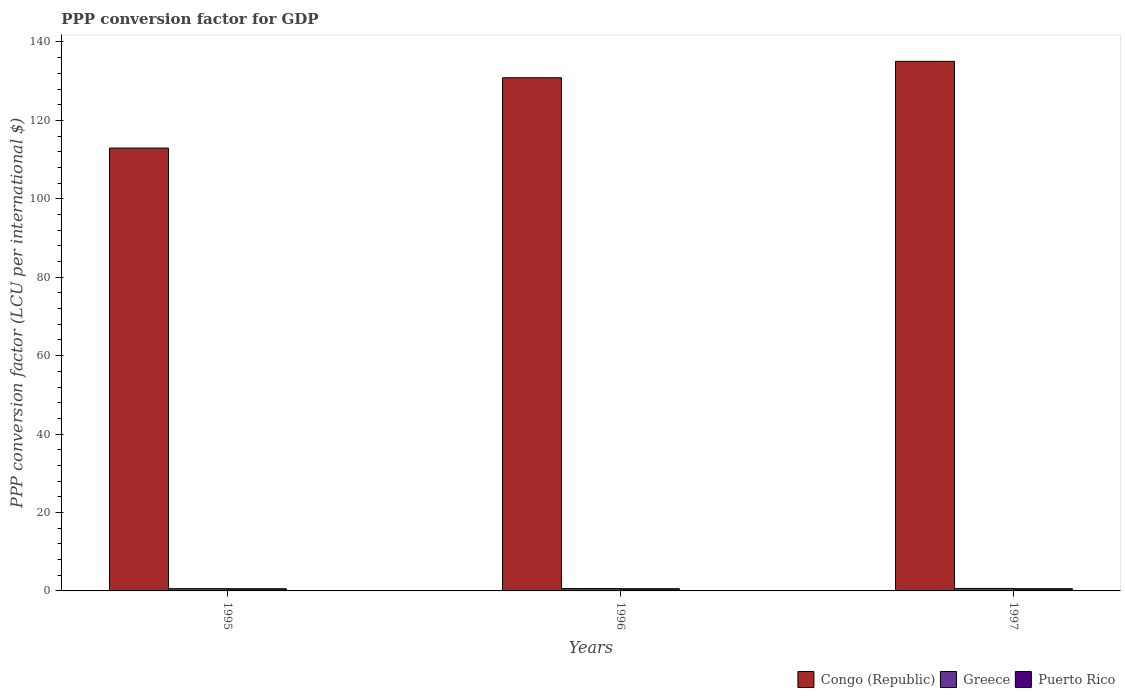How many different coloured bars are there?
Give a very brief answer. 3. How many groups of bars are there?
Keep it short and to the point. 3. Are the number of bars per tick equal to the number of legend labels?
Make the answer very short. Yes. Are the number of bars on each tick of the X-axis equal?
Provide a succinct answer. Yes. How many bars are there on the 3rd tick from the left?
Offer a very short reply. 3. How many bars are there on the 2nd tick from the right?
Offer a terse response. 3. What is the label of the 1st group of bars from the left?
Ensure brevity in your answer.  1995. What is the PPP conversion factor for GDP in Puerto Rico in 1995?
Provide a short and direct response. 0.55. Across all years, what is the maximum PPP conversion factor for GDP in Puerto Rico?
Offer a terse response. 0.57. Across all years, what is the minimum PPP conversion factor for GDP in Puerto Rico?
Provide a succinct answer. 0.55. In which year was the PPP conversion factor for GDP in Congo (Republic) maximum?
Your response must be concise. 1997. In which year was the PPP conversion factor for GDP in Congo (Republic) minimum?
Provide a succinct answer. 1995. What is the total PPP conversion factor for GDP in Greece in the graph?
Ensure brevity in your answer.  1.81. What is the difference between the PPP conversion factor for GDP in Congo (Republic) in 1995 and that in 1997?
Your answer should be very brief. -22.12. What is the difference between the PPP conversion factor for GDP in Puerto Rico in 1997 and the PPP conversion factor for GDP in Congo (Republic) in 1996?
Keep it short and to the point. -130.3. What is the average PPP conversion factor for GDP in Greece per year?
Provide a short and direct response. 0.6. In the year 1995, what is the difference between the PPP conversion factor for GDP in Greece and PPP conversion factor for GDP in Puerto Rico?
Your answer should be very brief. 0.02. In how many years, is the PPP conversion factor for GDP in Puerto Rico greater than 28 LCU?
Your answer should be compact. 0. What is the ratio of the PPP conversion factor for GDP in Congo (Republic) in 1996 to that in 1997?
Provide a short and direct response. 0.97. Is the PPP conversion factor for GDP in Puerto Rico in 1996 less than that in 1997?
Give a very brief answer. Yes. Is the difference between the PPP conversion factor for GDP in Greece in 1996 and 1997 greater than the difference between the PPP conversion factor for GDP in Puerto Rico in 1996 and 1997?
Your answer should be very brief. No. What is the difference between the highest and the second highest PPP conversion factor for GDP in Puerto Rico?
Make the answer very short. 0.01. What is the difference between the highest and the lowest PPP conversion factor for GDP in Greece?
Provide a succinct answer. 0.06. In how many years, is the PPP conversion factor for GDP in Congo (Republic) greater than the average PPP conversion factor for GDP in Congo (Republic) taken over all years?
Make the answer very short. 2. What does the 3rd bar from the left in 1995 represents?
Your answer should be very brief. Puerto Rico. Is it the case that in every year, the sum of the PPP conversion factor for GDP in Congo (Republic) and PPP conversion factor for GDP in Greece is greater than the PPP conversion factor for GDP in Puerto Rico?
Provide a succinct answer. Yes. How many bars are there?
Your response must be concise. 9. Are all the bars in the graph horizontal?
Provide a short and direct response. No. Does the graph contain grids?
Ensure brevity in your answer.  No. What is the title of the graph?
Ensure brevity in your answer.  PPP conversion factor for GDP. What is the label or title of the Y-axis?
Keep it short and to the point. PPP conversion factor (LCU per international $). What is the PPP conversion factor (LCU per international $) in Congo (Republic) in 1995?
Keep it short and to the point. 112.94. What is the PPP conversion factor (LCU per international $) in Greece in 1995?
Your answer should be compact. 0.57. What is the PPP conversion factor (LCU per international $) of Puerto Rico in 1995?
Make the answer very short. 0.55. What is the PPP conversion factor (LCU per international $) in Congo (Republic) in 1996?
Your response must be concise. 130.87. What is the PPP conversion factor (LCU per international $) of Greece in 1996?
Offer a terse response. 0.61. What is the PPP conversion factor (LCU per international $) of Puerto Rico in 1996?
Make the answer very short. 0.56. What is the PPP conversion factor (LCU per international $) of Congo (Republic) in 1997?
Your answer should be compact. 135.06. What is the PPP conversion factor (LCU per international $) in Greece in 1997?
Offer a terse response. 0.63. What is the PPP conversion factor (LCU per international $) in Puerto Rico in 1997?
Provide a short and direct response. 0.57. Across all years, what is the maximum PPP conversion factor (LCU per international $) of Congo (Republic)?
Your answer should be very brief. 135.06. Across all years, what is the maximum PPP conversion factor (LCU per international $) in Greece?
Your answer should be very brief. 0.63. Across all years, what is the maximum PPP conversion factor (LCU per international $) of Puerto Rico?
Your response must be concise. 0.57. Across all years, what is the minimum PPP conversion factor (LCU per international $) of Congo (Republic)?
Make the answer very short. 112.94. Across all years, what is the minimum PPP conversion factor (LCU per international $) in Greece?
Provide a succinct answer. 0.57. Across all years, what is the minimum PPP conversion factor (LCU per international $) in Puerto Rico?
Your answer should be very brief. 0.55. What is the total PPP conversion factor (LCU per international $) of Congo (Republic) in the graph?
Your response must be concise. 378.87. What is the total PPP conversion factor (LCU per international $) of Greece in the graph?
Your response must be concise. 1.81. What is the total PPP conversion factor (LCU per international $) of Puerto Rico in the graph?
Your answer should be compact. 1.69. What is the difference between the PPP conversion factor (LCU per international $) of Congo (Republic) in 1995 and that in 1996?
Provide a short and direct response. -17.93. What is the difference between the PPP conversion factor (LCU per international $) of Greece in 1995 and that in 1996?
Provide a succinct answer. -0.03. What is the difference between the PPP conversion factor (LCU per international $) in Puerto Rico in 1995 and that in 1996?
Provide a succinct answer. -0.01. What is the difference between the PPP conversion factor (LCU per international $) in Congo (Republic) in 1995 and that in 1997?
Keep it short and to the point. -22.12. What is the difference between the PPP conversion factor (LCU per international $) of Greece in 1995 and that in 1997?
Your response must be concise. -0.06. What is the difference between the PPP conversion factor (LCU per international $) in Puerto Rico in 1995 and that in 1997?
Offer a very short reply. -0.02. What is the difference between the PPP conversion factor (LCU per international $) of Congo (Republic) in 1996 and that in 1997?
Ensure brevity in your answer.  -4.19. What is the difference between the PPP conversion factor (LCU per international $) in Greece in 1996 and that in 1997?
Offer a very short reply. -0.03. What is the difference between the PPP conversion factor (LCU per international $) in Puerto Rico in 1996 and that in 1997?
Offer a very short reply. -0.01. What is the difference between the PPP conversion factor (LCU per international $) of Congo (Republic) in 1995 and the PPP conversion factor (LCU per international $) of Greece in 1996?
Give a very brief answer. 112.34. What is the difference between the PPP conversion factor (LCU per international $) in Congo (Republic) in 1995 and the PPP conversion factor (LCU per international $) in Puerto Rico in 1996?
Your response must be concise. 112.38. What is the difference between the PPP conversion factor (LCU per international $) in Greece in 1995 and the PPP conversion factor (LCU per international $) in Puerto Rico in 1996?
Ensure brevity in your answer.  0.01. What is the difference between the PPP conversion factor (LCU per international $) of Congo (Republic) in 1995 and the PPP conversion factor (LCU per international $) of Greece in 1997?
Provide a short and direct response. 112.31. What is the difference between the PPP conversion factor (LCU per international $) of Congo (Republic) in 1995 and the PPP conversion factor (LCU per international $) of Puerto Rico in 1997?
Your answer should be very brief. 112.37. What is the difference between the PPP conversion factor (LCU per international $) of Greece in 1995 and the PPP conversion factor (LCU per international $) of Puerto Rico in 1997?
Ensure brevity in your answer.  0. What is the difference between the PPP conversion factor (LCU per international $) in Congo (Republic) in 1996 and the PPP conversion factor (LCU per international $) in Greece in 1997?
Your response must be concise. 130.24. What is the difference between the PPP conversion factor (LCU per international $) of Congo (Republic) in 1996 and the PPP conversion factor (LCU per international $) of Puerto Rico in 1997?
Your answer should be very brief. 130.3. What is the difference between the PPP conversion factor (LCU per international $) in Greece in 1996 and the PPP conversion factor (LCU per international $) in Puerto Rico in 1997?
Offer a very short reply. 0.03. What is the average PPP conversion factor (LCU per international $) of Congo (Republic) per year?
Keep it short and to the point. 126.29. What is the average PPP conversion factor (LCU per international $) of Greece per year?
Offer a terse response. 0.6. What is the average PPP conversion factor (LCU per international $) of Puerto Rico per year?
Offer a terse response. 0.56. In the year 1995, what is the difference between the PPP conversion factor (LCU per international $) of Congo (Republic) and PPP conversion factor (LCU per international $) of Greece?
Ensure brevity in your answer.  112.37. In the year 1995, what is the difference between the PPP conversion factor (LCU per international $) in Congo (Republic) and PPP conversion factor (LCU per international $) in Puerto Rico?
Your answer should be very brief. 112.39. In the year 1995, what is the difference between the PPP conversion factor (LCU per international $) in Greece and PPP conversion factor (LCU per international $) in Puerto Rico?
Make the answer very short. 0.02. In the year 1996, what is the difference between the PPP conversion factor (LCU per international $) of Congo (Republic) and PPP conversion factor (LCU per international $) of Greece?
Your answer should be compact. 130.27. In the year 1996, what is the difference between the PPP conversion factor (LCU per international $) of Congo (Republic) and PPP conversion factor (LCU per international $) of Puerto Rico?
Ensure brevity in your answer.  130.31. In the year 1996, what is the difference between the PPP conversion factor (LCU per international $) in Greece and PPP conversion factor (LCU per international $) in Puerto Rico?
Your answer should be very brief. 0.04. In the year 1997, what is the difference between the PPP conversion factor (LCU per international $) in Congo (Republic) and PPP conversion factor (LCU per international $) in Greece?
Provide a short and direct response. 134.43. In the year 1997, what is the difference between the PPP conversion factor (LCU per international $) of Congo (Republic) and PPP conversion factor (LCU per international $) of Puerto Rico?
Provide a succinct answer. 134.49. In the year 1997, what is the difference between the PPP conversion factor (LCU per international $) in Greece and PPP conversion factor (LCU per international $) in Puerto Rico?
Provide a succinct answer. 0.06. What is the ratio of the PPP conversion factor (LCU per international $) of Congo (Republic) in 1995 to that in 1996?
Provide a succinct answer. 0.86. What is the ratio of the PPP conversion factor (LCU per international $) in Greece in 1995 to that in 1996?
Keep it short and to the point. 0.95. What is the ratio of the PPP conversion factor (LCU per international $) in Puerto Rico in 1995 to that in 1996?
Provide a short and direct response. 0.99. What is the ratio of the PPP conversion factor (LCU per international $) of Congo (Republic) in 1995 to that in 1997?
Your answer should be very brief. 0.84. What is the ratio of the PPP conversion factor (LCU per international $) in Greece in 1995 to that in 1997?
Your answer should be very brief. 0.91. What is the ratio of the PPP conversion factor (LCU per international $) in Puerto Rico in 1995 to that in 1997?
Make the answer very short. 0.97. What is the ratio of the PPP conversion factor (LCU per international $) in Congo (Republic) in 1996 to that in 1997?
Keep it short and to the point. 0.97. What is the ratio of the PPP conversion factor (LCU per international $) of Greece in 1996 to that in 1997?
Your answer should be compact. 0.96. What is the ratio of the PPP conversion factor (LCU per international $) of Puerto Rico in 1996 to that in 1997?
Your response must be concise. 0.99. What is the difference between the highest and the second highest PPP conversion factor (LCU per international $) of Congo (Republic)?
Ensure brevity in your answer.  4.19. What is the difference between the highest and the second highest PPP conversion factor (LCU per international $) in Greece?
Ensure brevity in your answer.  0.03. What is the difference between the highest and the second highest PPP conversion factor (LCU per international $) in Puerto Rico?
Offer a very short reply. 0.01. What is the difference between the highest and the lowest PPP conversion factor (LCU per international $) of Congo (Republic)?
Ensure brevity in your answer.  22.12. What is the difference between the highest and the lowest PPP conversion factor (LCU per international $) of Greece?
Give a very brief answer. 0.06. What is the difference between the highest and the lowest PPP conversion factor (LCU per international $) of Puerto Rico?
Your response must be concise. 0.02. 